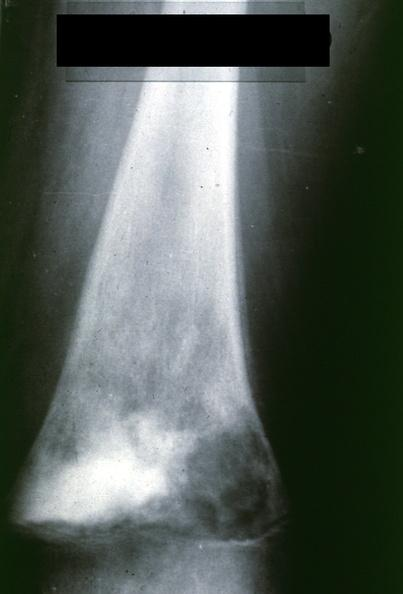what does this image show?
Answer the question using a single word or phrase. X-ray distal femur ap view lytic and blastic lesion 12 yo female three month history painful knee outside study case lateral view is 